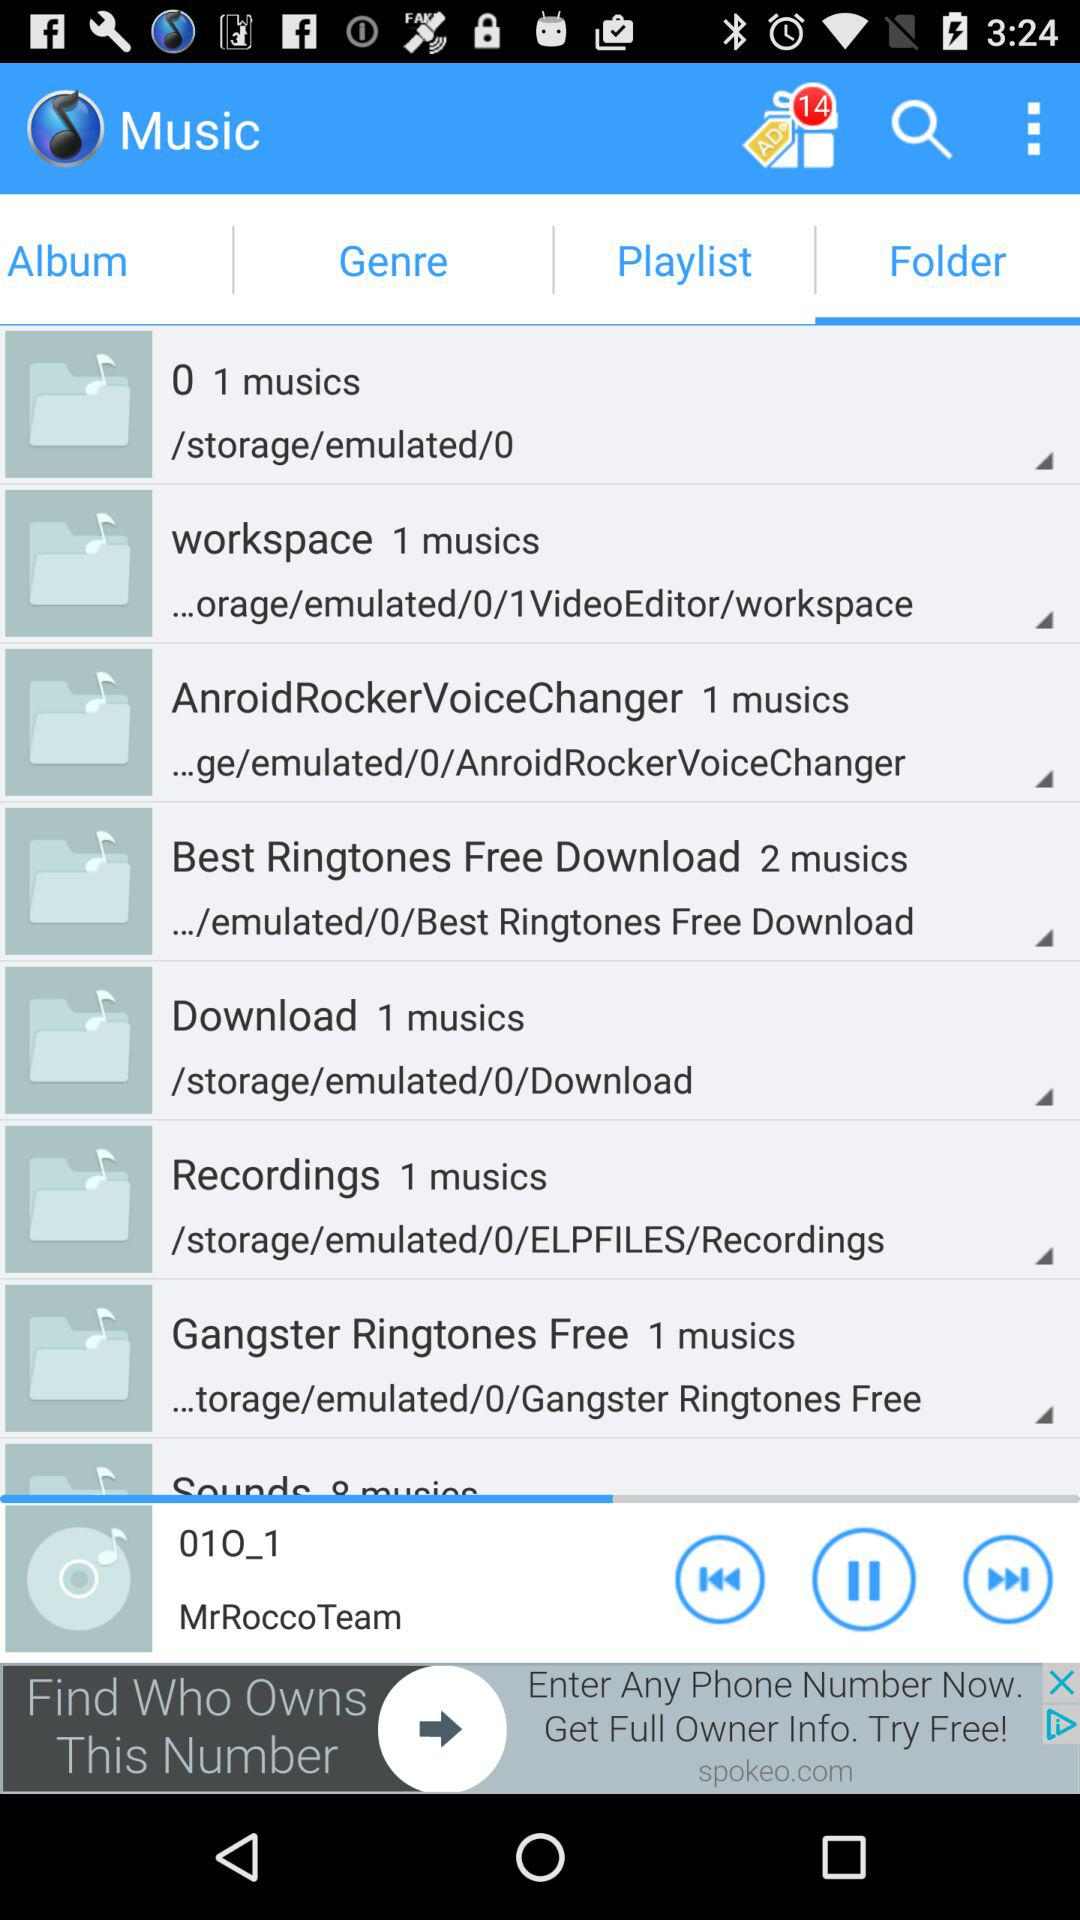How many musics are in the folder 'Sounds'?
Answer the question using a single word or phrase. 8 